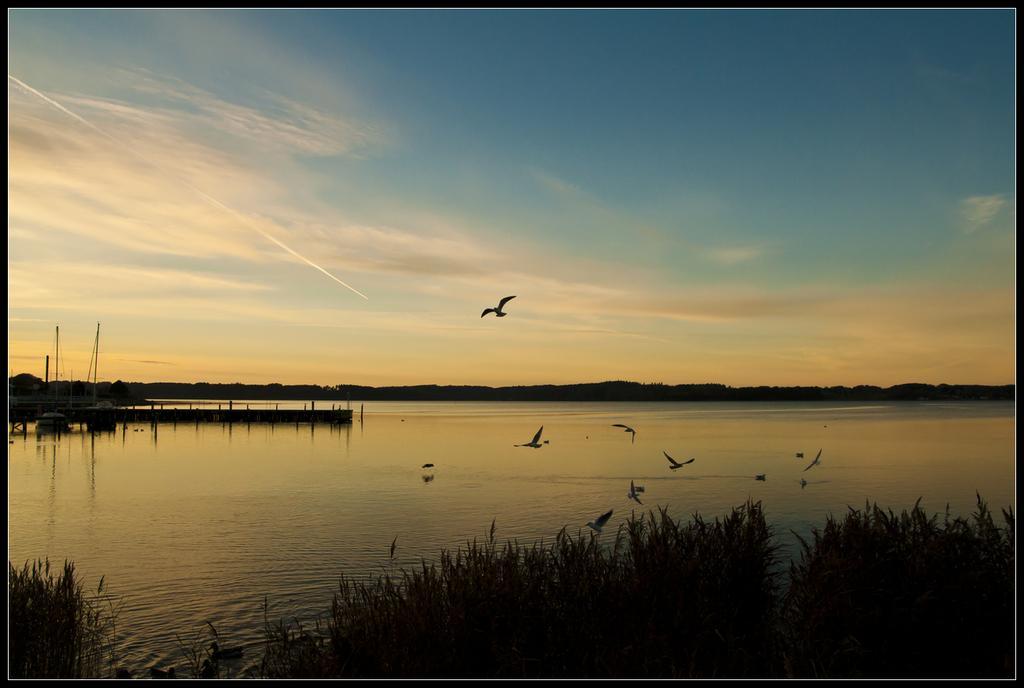Please provide a concise description of this image. At the bottom of the picture, we see the crops or the grass. Beside that, we see the birds are flying in the sky. Here, we see water and this water might be in the lake. On the left side, we see something which looks like a bridge. There are trees in the background. At the top, we see the sky. 